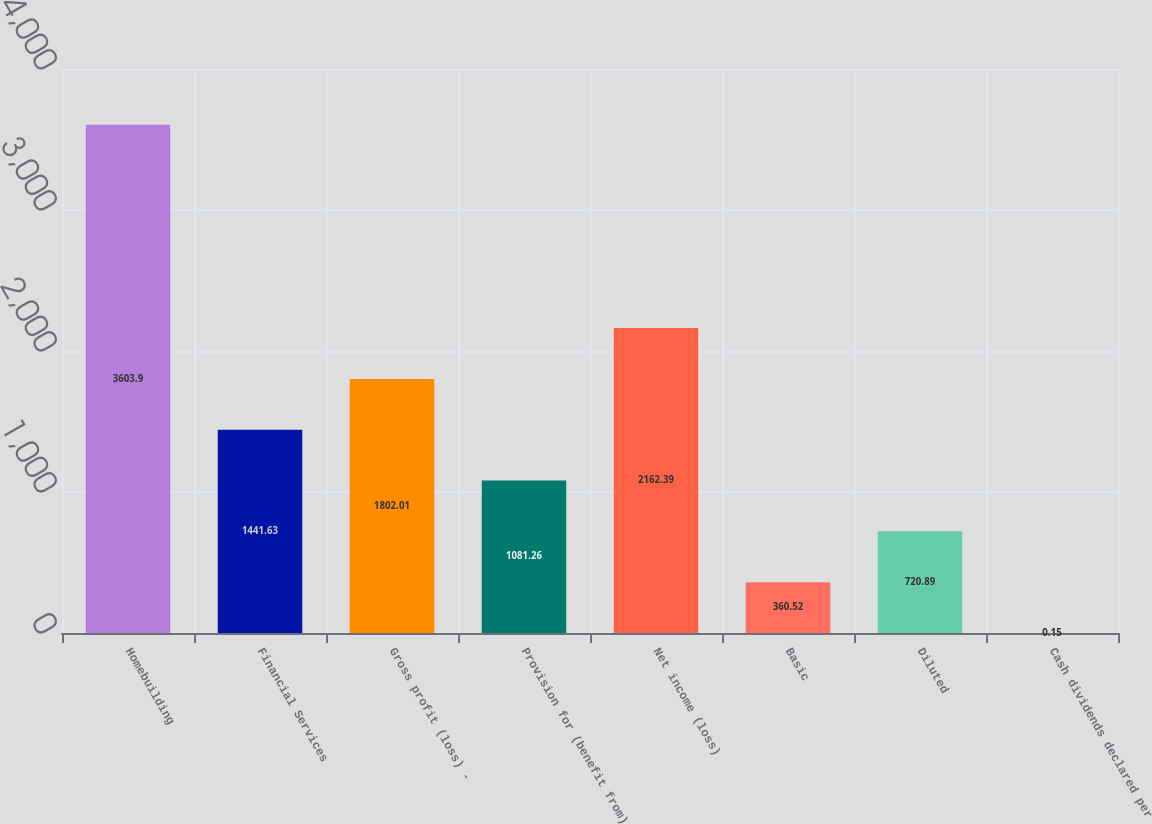Convert chart to OTSL. <chart><loc_0><loc_0><loc_500><loc_500><bar_chart><fcel>Homebuilding<fcel>Financial Services<fcel>Gross profit (loss) -<fcel>Provision for (benefit from)<fcel>Net income (loss)<fcel>Basic<fcel>Diluted<fcel>Cash dividends declared per<nl><fcel>3603.9<fcel>1441.63<fcel>1802.01<fcel>1081.26<fcel>2162.39<fcel>360.52<fcel>720.89<fcel>0.15<nl></chart> 